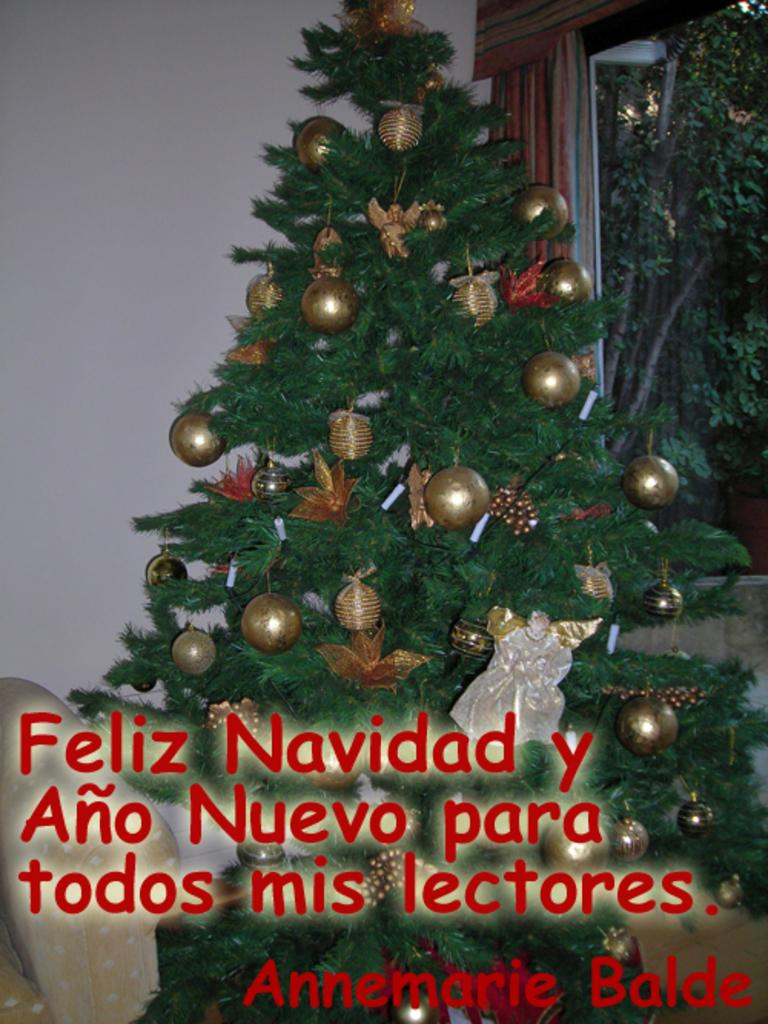What is the main subject of the image? There is a Christmas tree in the image. What else can be seen in the image besides the Christmas tree? There is some text and decorative items in the image. What is visible in the background of the image? There are trees visible in the background of the image. Can you tell me how many bears are sitting on the Christmas tree in the image? There are no bears present in the image; it features a Christmas tree with text and decorative items. What type of market is visible in the background of the image? There is no market visible in the image; it features trees in the background. 